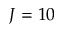<formula> <loc_0><loc_0><loc_500><loc_500>J = 1 0</formula> 